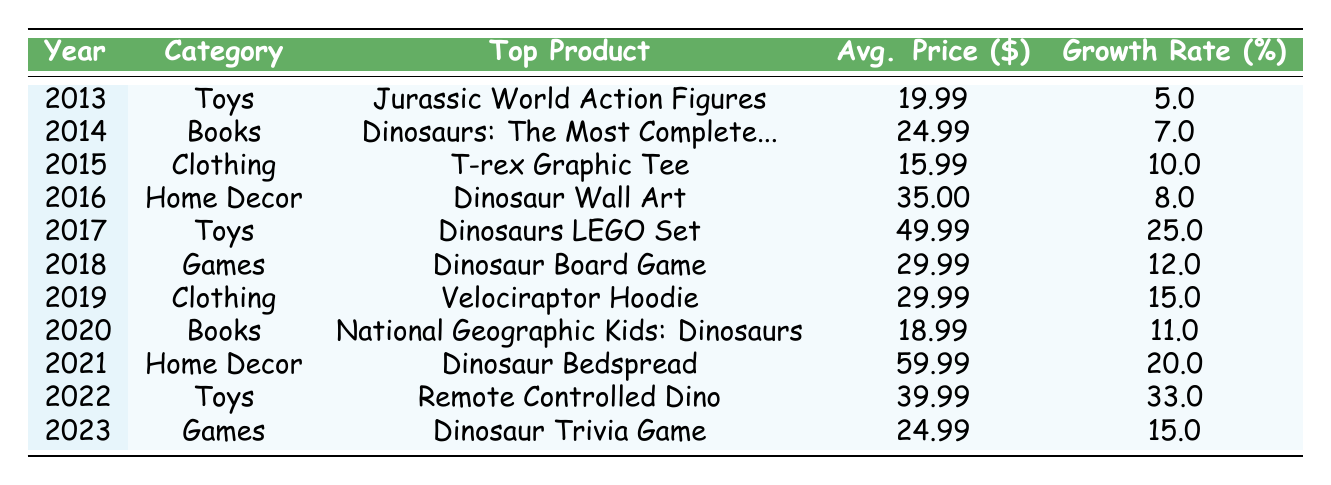What was the top-selling dinosaur-themed product in 2022? Referring to the table, in 2022, the total sales for toys were 200000, and the top product listed for that year is "Remote Controlled Dino".
Answer: Remote Controlled Dino Which category had the highest sales in 2017? In 2017, the table shows that toys had total sales of 150000, which is higher than any other category's sales in that year.
Answer: Toys Was there an increase in average price for dinosaur merchandise from 2013 to 2023? Reviewing the table, the average price in 2013 was 19.99, and in 2023, it was 24.99. Since the price increased from 19.99 to 24.99, the answer is yes.
Answer: Yes What is the growth rate of the top product in 2021 compared to the top product in 2013? The growth rate of "Dinosaur Bedspread" in 2021 is 20.0, and for "Jurassic World Action Figures" in 2013, it is 5.0. Subtracting gives us 20.0 - 5.0 = 15.0. Therefore, there was an increase of 15.0 in growth rate.
Answer: 15.0 In how many years did clothing reach average prices over 25 dollars? Looking at the table, the only years where clothing had an average price over 25 dollars are 2019 (29.99). Thus, it occurred in 1 year.
Answer: 1 year 